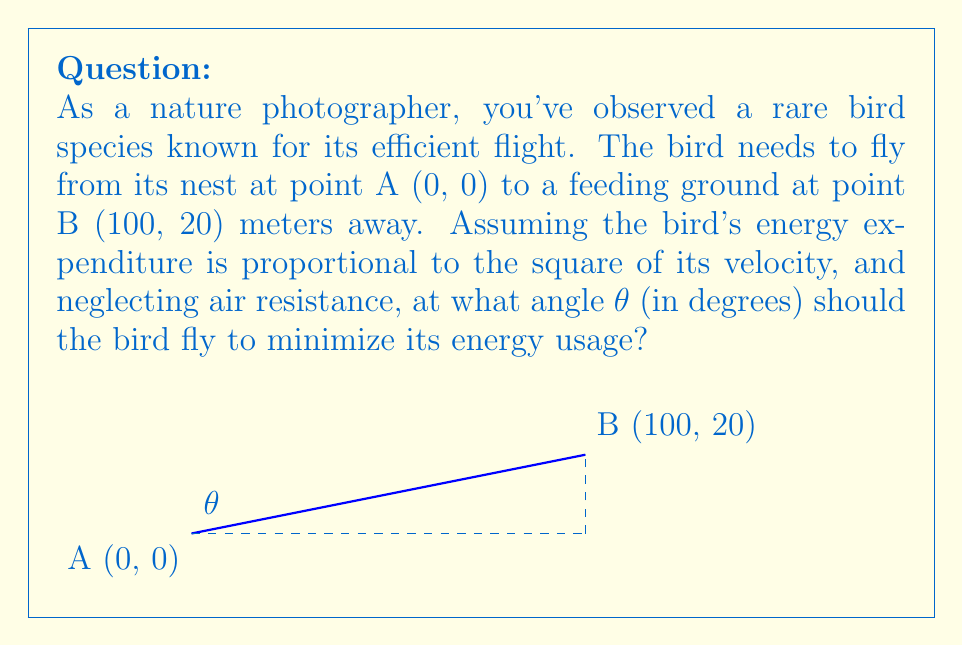Can you answer this question? Let's approach this step-by-step:

1) The bird's flight path can be represented as a straight line from A to B. The energy expenditure is proportional to the square of the velocity, which is inversely proportional to the time taken.

2) The time taken is proportional to the distance traveled. So, to minimize energy, we need to minimize the distance.

3) The distance d between two points (x₁, y₁) and (x₂, y₂) is given by:

   $$d = \sqrt{(x_2 - x_1)^2 + (y_2 - y_1)^2}$$

4) In our case, (x₁, y₁) = (0, 0) and (x₂, y₂) = (100, 20). So:

   $$d = \sqrt{100^2 + 20^2} = \sqrt{10400} = 102$$

5) The angle θ is given by:

   $$\tan \theta = \frac{20}{100} = 0.2$$

6) To find θ, we use the inverse tangent function:

   $$\theta = \arctan(0.2)$$

7) Converting to degrees:

   $$\theta = \arctan(0.2) \cdot \frac{180}{\pi} \approx 11.31°$$

Therefore, the bird should fly at an angle of approximately 11.31° to the horizontal to minimize its energy expenditure.
Answer: $11.31°$ 